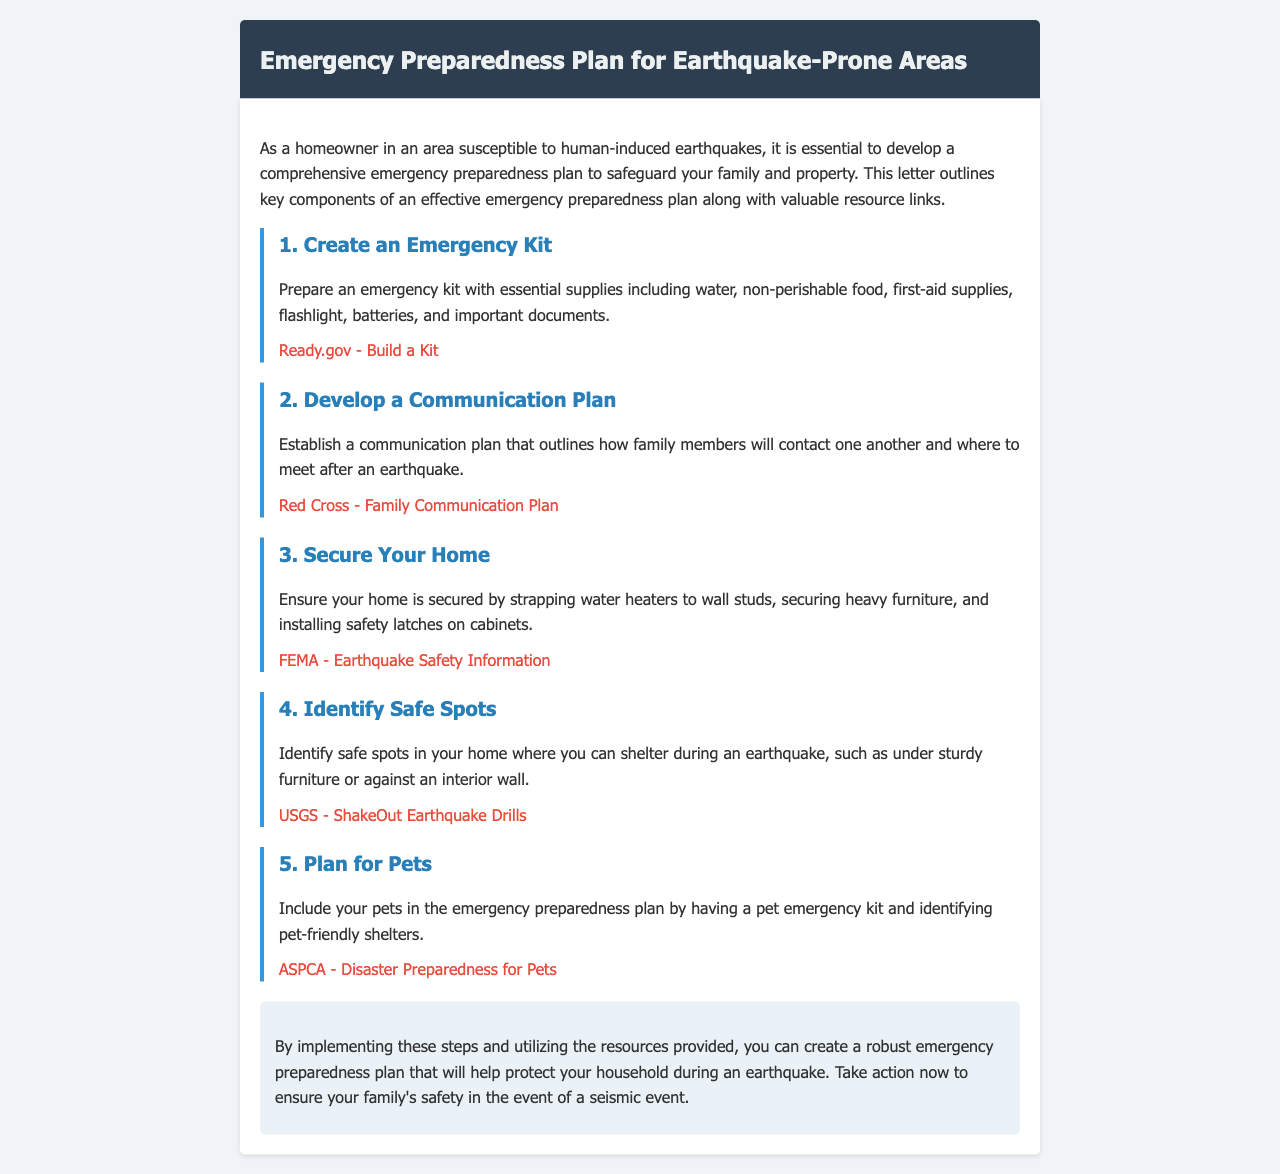what is the first component of the emergency preparedness plan? The first component listed in the document is to create an emergency kit.
Answer: create an emergency kit how many key components are outlined in the document? There are five key components mentioned in the document.
Answer: five which organization provides information on building an emergency kit? The resource link provided for building an emergency kit is from Ready.gov.
Answer: Ready.gov what should be secured to wall studs in your home? The document specifically mentions strapping water heaters to wall studs.
Answer: water heaters what is one way to involve pets in the emergency preparedness plan? The document suggests having a pet emergency kit as a way to include pets.
Answer: pet emergency kit which document section focuses on safe spots during an earthquake? The section titled "Identify Safe Spots" addresses where to shelter during an earthquake.
Answer: Identify Safe Spots what type of plan should be developed for family members after an earthquake? A communication plan should be developed for family members.
Answer: communication plan what is the purpose of the emergency preparedness plan outlined in the document? The purpose is to safeguard your family and property during earthquakes.
Answer: safeguard your family and property which organization's site offers disaster preparedness for pets? The ASPCA's website provides disaster preparedness information for pets.
Answer: ASPCA 